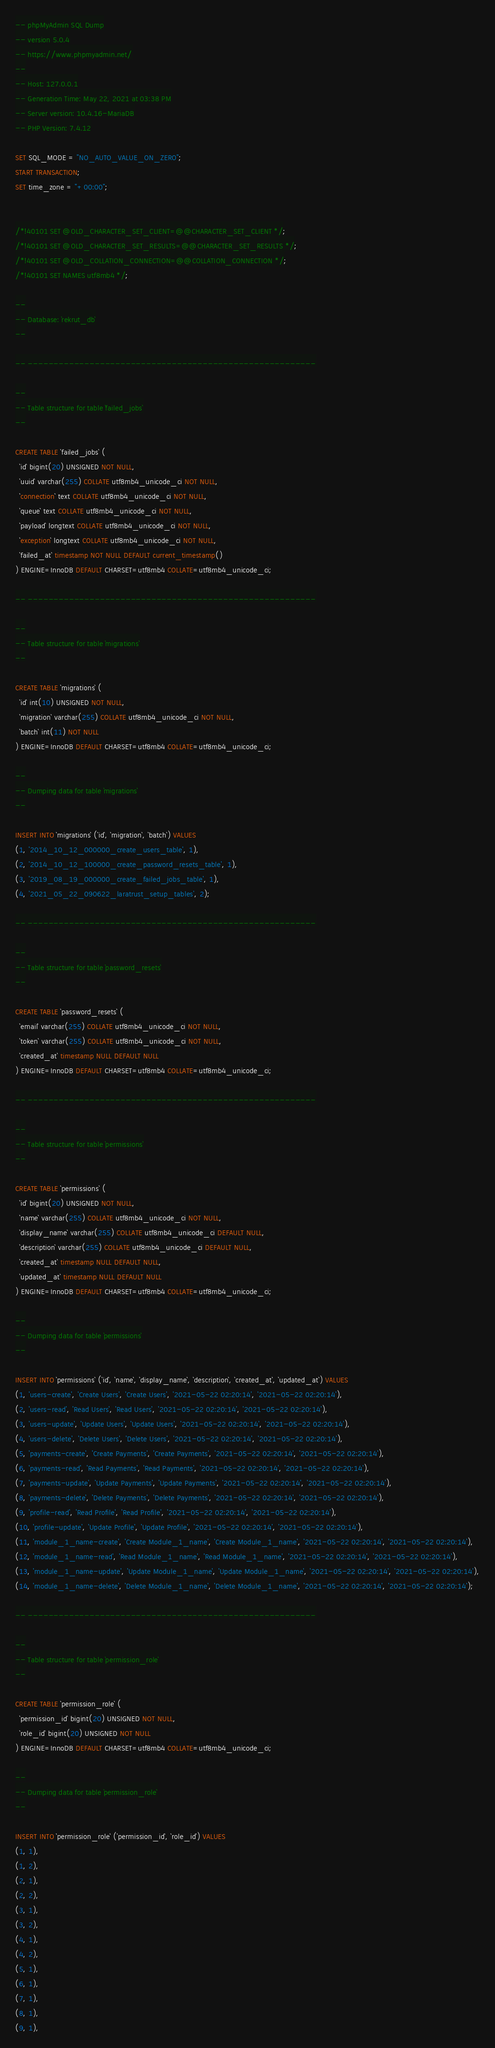Convert code to text. <code><loc_0><loc_0><loc_500><loc_500><_SQL_>-- phpMyAdmin SQL Dump
-- version 5.0.4
-- https://www.phpmyadmin.net/
--
-- Host: 127.0.0.1
-- Generation Time: May 22, 2021 at 03:38 PM
-- Server version: 10.4.16-MariaDB
-- PHP Version: 7.4.12

SET SQL_MODE = "NO_AUTO_VALUE_ON_ZERO";
START TRANSACTION;
SET time_zone = "+00:00";


/*!40101 SET @OLD_CHARACTER_SET_CLIENT=@@CHARACTER_SET_CLIENT */;
/*!40101 SET @OLD_CHARACTER_SET_RESULTS=@@CHARACTER_SET_RESULTS */;
/*!40101 SET @OLD_COLLATION_CONNECTION=@@COLLATION_CONNECTION */;
/*!40101 SET NAMES utf8mb4 */;

--
-- Database: `rekrut_db`
--

-- --------------------------------------------------------

--
-- Table structure for table `failed_jobs`
--

CREATE TABLE `failed_jobs` (
  `id` bigint(20) UNSIGNED NOT NULL,
  `uuid` varchar(255) COLLATE utf8mb4_unicode_ci NOT NULL,
  `connection` text COLLATE utf8mb4_unicode_ci NOT NULL,
  `queue` text COLLATE utf8mb4_unicode_ci NOT NULL,
  `payload` longtext COLLATE utf8mb4_unicode_ci NOT NULL,
  `exception` longtext COLLATE utf8mb4_unicode_ci NOT NULL,
  `failed_at` timestamp NOT NULL DEFAULT current_timestamp()
) ENGINE=InnoDB DEFAULT CHARSET=utf8mb4 COLLATE=utf8mb4_unicode_ci;

-- --------------------------------------------------------

--
-- Table structure for table `migrations`
--

CREATE TABLE `migrations` (
  `id` int(10) UNSIGNED NOT NULL,
  `migration` varchar(255) COLLATE utf8mb4_unicode_ci NOT NULL,
  `batch` int(11) NOT NULL
) ENGINE=InnoDB DEFAULT CHARSET=utf8mb4 COLLATE=utf8mb4_unicode_ci;

--
-- Dumping data for table `migrations`
--

INSERT INTO `migrations` (`id`, `migration`, `batch`) VALUES
(1, '2014_10_12_000000_create_users_table', 1),
(2, '2014_10_12_100000_create_password_resets_table', 1),
(3, '2019_08_19_000000_create_failed_jobs_table', 1),
(4, '2021_05_22_090622_laratrust_setup_tables', 2);

-- --------------------------------------------------------

--
-- Table structure for table `password_resets`
--

CREATE TABLE `password_resets` (
  `email` varchar(255) COLLATE utf8mb4_unicode_ci NOT NULL,
  `token` varchar(255) COLLATE utf8mb4_unicode_ci NOT NULL,
  `created_at` timestamp NULL DEFAULT NULL
) ENGINE=InnoDB DEFAULT CHARSET=utf8mb4 COLLATE=utf8mb4_unicode_ci;

-- --------------------------------------------------------

--
-- Table structure for table `permissions`
--

CREATE TABLE `permissions` (
  `id` bigint(20) UNSIGNED NOT NULL,
  `name` varchar(255) COLLATE utf8mb4_unicode_ci NOT NULL,
  `display_name` varchar(255) COLLATE utf8mb4_unicode_ci DEFAULT NULL,
  `description` varchar(255) COLLATE utf8mb4_unicode_ci DEFAULT NULL,
  `created_at` timestamp NULL DEFAULT NULL,
  `updated_at` timestamp NULL DEFAULT NULL
) ENGINE=InnoDB DEFAULT CHARSET=utf8mb4 COLLATE=utf8mb4_unicode_ci;

--
-- Dumping data for table `permissions`
--

INSERT INTO `permissions` (`id`, `name`, `display_name`, `description`, `created_at`, `updated_at`) VALUES
(1, 'users-create', 'Create Users', 'Create Users', '2021-05-22 02:20:14', '2021-05-22 02:20:14'),
(2, 'users-read', 'Read Users', 'Read Users', '2021-05-22 02:20:14', '2021-05-22 02:20:14'),
(3, 'users-update', 'Update Users', 'Update Users', '2021-05-22 02:20:14', '2021-05-22 02:20:14'),
(4, 'users-delete', 'Delete Users', 'Delete Users', '2021-05-22 02:20:14', '2021-05-22 02:20:14'),
(5, 'payments-create', 'Create Payments', 'Create Payments', '2021-05-22 02:20:14', '2021-05-22 02:20:14'),
(6, 'payments-read', 'Read Payments', 'Read Payments', '2021-05-22 02:20:14', '2021-05-22 02:20:14'),
(7, 'payments-update', 'Update Payments', 'Update Payments', '2021-05-22 02:20:14', '2021-05-22 02:20:14'),
(8, 'payments-delete', 'Delete Payments', 'Delete Payments', '2021-05-22 02:20:14', '2021-05-22 02:20:14'),
(9, 'profile-read', 'Read Profile', 'Read Profile', '2021-05-22 02:20:14', '2021-05-22 02:20:14'),
(10, 'profile-update', 'Update Profile', 'Update Profile', '2021-05-22 02:20:14', '2021-05-22 02:20:14'),
(11, 'module_1_name-create', 'Create Module_1_name', 'Create Module_1_name', '2021-05-22 02:20:14', '2021-05-22 02:20:14'),
(12, 'module_1_name-read', 'Read Module_1_name', 'Read Module_1_name', '2021-05-22 02:20:14', '2021-05-22 02:20:14'),
(13, 'module_1_name-update', 'Update Module_1_name', 'Update Module_1_name', '2021-05-22 02:20:14', '2021-05-22 02:20:14'),
(14, 'module_1_name-delete', 'Delete Module_1_name', 'Delete Module_1_name', '2021-05-22 02:20:14', '2021-05-22 02:20:14');

-- --------------------------------------------------------

--
-- Table structure for table `permission_role`
--

CREATE TABLE `permission_role` (
  `permission_id` bigint(20) UNSIGNED NOT NULL,
  `role_id` bigint(20) UNSIGNED NOT NULL
) ENGINE=InnoDB DEFAULT CHARSET=utf8mb4 COLLATE=utf8mb4_unicode_ci;

--
-- Dumping data for table `permission_role`
--

INSERT INTO `permission_role` (`permission_id`, `role_id`) VALUES
(1, 1),
(1, 2),
(2, 1),
(2, 2),
(3, 1),
(3, 2),
(4, 1),
(4, 2),
(5, 1),
(6, 1),
(7, 1),
(8, 1),
(9, 1),</code> 